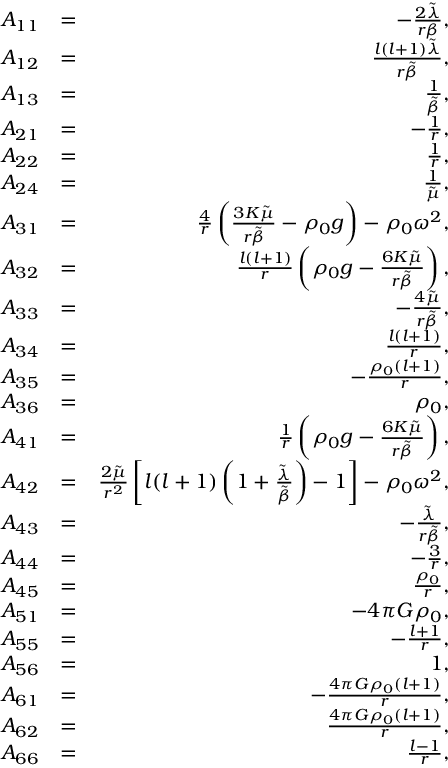Convert formula to latex. <formula><loc_0><loc_0><loc_500><loc_500>\begin{array} { r l r } { A _ { 1 1 } } & { = } & { - \frac { 2 \tilde { \lambda } } { r \beta } , } \\ { A _ { 1 2 } } & { = } & { \frac { l ( l + 1 ) \tilde { \lambda } } { r \tilde { \beta } } , } \\ { A _ { 1 3 } } & { = } & { \frac { 1 } { \tilde { \beta } } , } \\ { A _ { 2 1 } } & { = } & { - \frac { 1 } { r } , } \\ { A _ { 2 2 } } & { = } & { \frac { 1 } { r } , } \\ { A _ { 2 4 } } & { = } & { \frac { 1 } { \tilde { \mu } } , } \\ { A _ { 3 1 } } & { = } & { \frac { 4 } { r } \left ( \frac { 3 K \tilde { \mu } } { r \tilde { \beta } } - \rho _ { 0 } g \right ) - \rho _ { 0 } \omega ^ { 2 } , } \\ { A _ { 3 2 } } & { = } & { \frac { l ( l + 1 ) } { r } \left ( \rho _ { 0 } g - \frac { 6 K \tilde { \mu } } { r \tilde { \beta } } \right ) , } \\ { A _ { 3 3 } } & { = } & { - \frac { 4 \tilde { \mu } } { r \tilde { \beta } } , } \\ { A _ { 3 4 } } & { = } & { \frac { l ( l + 1 ) } { r } , } \\ { A _ { 3 5 } } & { = } & { - \frac { \rho _ { 0 } ( l + 1 ) } { r } , } \\ { A _ { 3 6 } } & { = } & { \rho _ { 0 } , } \\ { A _ { 4 1 } } & { = } & { \frac { 1 } { r } \left ( \rho _ { 0 } g - \frac { 6 K \tilde { \mu } } { r \tilde { \beta } } \right ) , } \\ { A _ { 4 2 } } & { = } & { \frac { 2 \tilde { \mu } } { r ^ { 2 } } \left [ l ( l + 1 ) \left ( 1 + \frac { \tilde { \lambda } } { \tilde { \beta } } \right ) - 1 \right ] - \rho _ { 0 } \omega ^ { 2 } , } \\ { A _ { 4 3 } } & { = } & { - \frac { \tilde { \lambda } } { r \tilde { \beta } } , } \\ { A _ { 4 4 } } & { = } & { - \frac { 3 } { r } , } \\ { A _ { 4 5 } } & { = } & { \frac { \rho _ { 0 } } { r } , } \\ { A _ { 5 1 } } & { = } & { - 4 \pi G \rho _ { 0 } , } \\ { A _ { 5 5 } } & { = } & { - \frac { l + 1 } { r } , } \\ { A _ { 5 6 } } & { = } & { 1 , } \\ { A _ { 6 1 } } & { = } & { - \frac { 4 \pi G \rho _ { 0 } ( l + 1 ) } { r } , } \\ { A _ { 6 2 } } & { = } & { \frac { 4 \pi G \rho _ { 0 } ( l + 1 ) } { r } , } \\ { A _ { 6 6 } } & { = } & { \frac { l - 1 } { r } , } \end{array}</formula> 